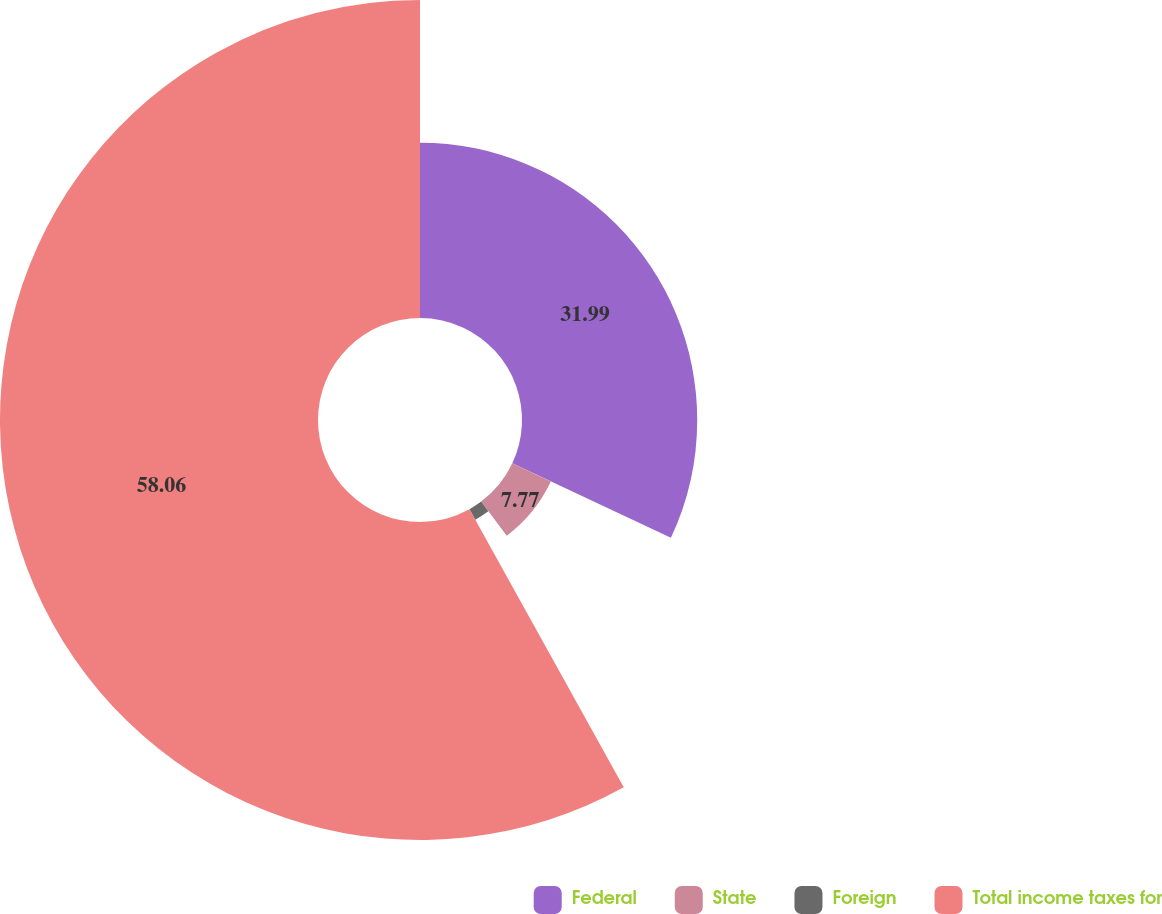<chart> <loc_0><loc_0><loc_500><loc_500><pie_chart><fcel>Federal<fcel>State<fcel>Foreign<fcel>Total income taxes for<nl><fcel>31.99%<fcel>7.77%<fcel>2.18%<fcel>58.06%<nl></chart> 